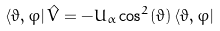Convert formula to latex. <formula><loc_0><loc_0><loc_500><loc_500>\langle \vartheta , \varphi | \, \hat { V } = - U _ { \alpha } \cos ^ { 2 } ( \vartheta ) \, \langle \vartheta , \varphi |</formula> 